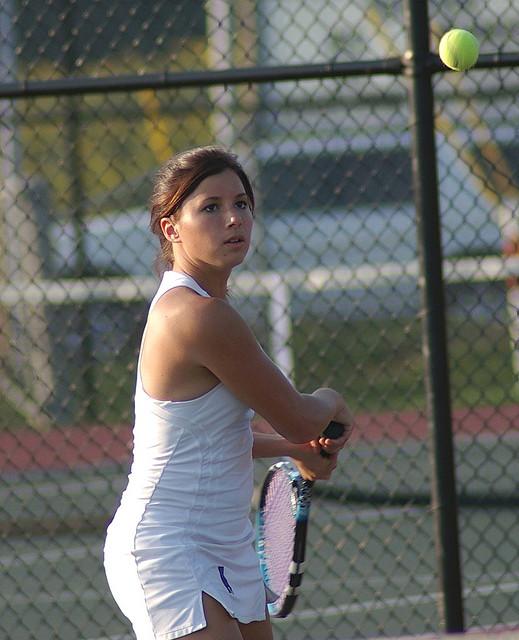Is the person trying to catch the ball?
Concise answer only. No. Is the woman's hair down?
Give a very brief answer. No. What color is the girl's hair?
Answer briefly. Brown. Is the girl swinging the bat?
Quick response, please. No. What color are the girl's shorts?
Concise answer only. White. What game is the equipment in the background for?
Quick response, please. Tennis. What game is she playing?
Short answer required. Tennis. What color is the woman's skirt?
Keep it brief. White. Are the sleeves on the girl's shirt long or short?
Write a very short answer. Short. What sport is being played?
Short answer required. Tennis. What color is the tennis ball?
Quick response, please. Green. 